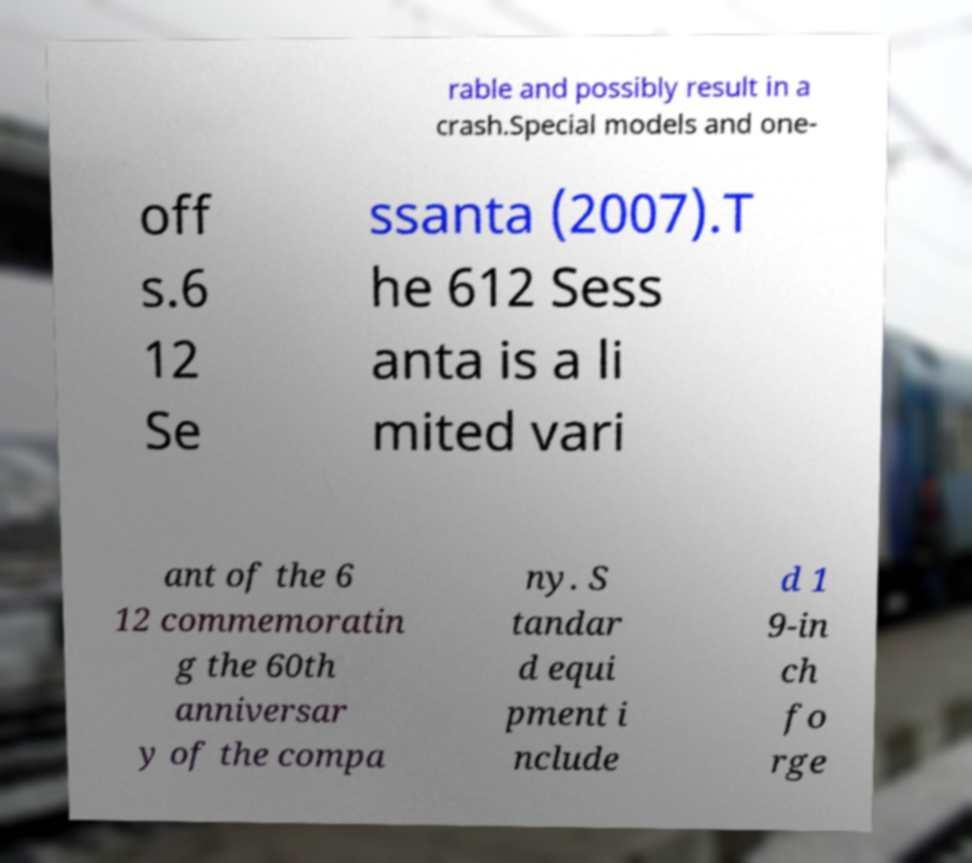I need the written content from this picture converted into text. Can you do that? rable and possibly result in a crash.Special models and one- off s.6 12 Se ssanta (2007).T he 612 Sess anta is a li mited vari ant of the 6 12 commemoratin g the 60th anniversar y of the compa ny. S tandar d equi pment i nclude d 1 9-in ch fo rge 